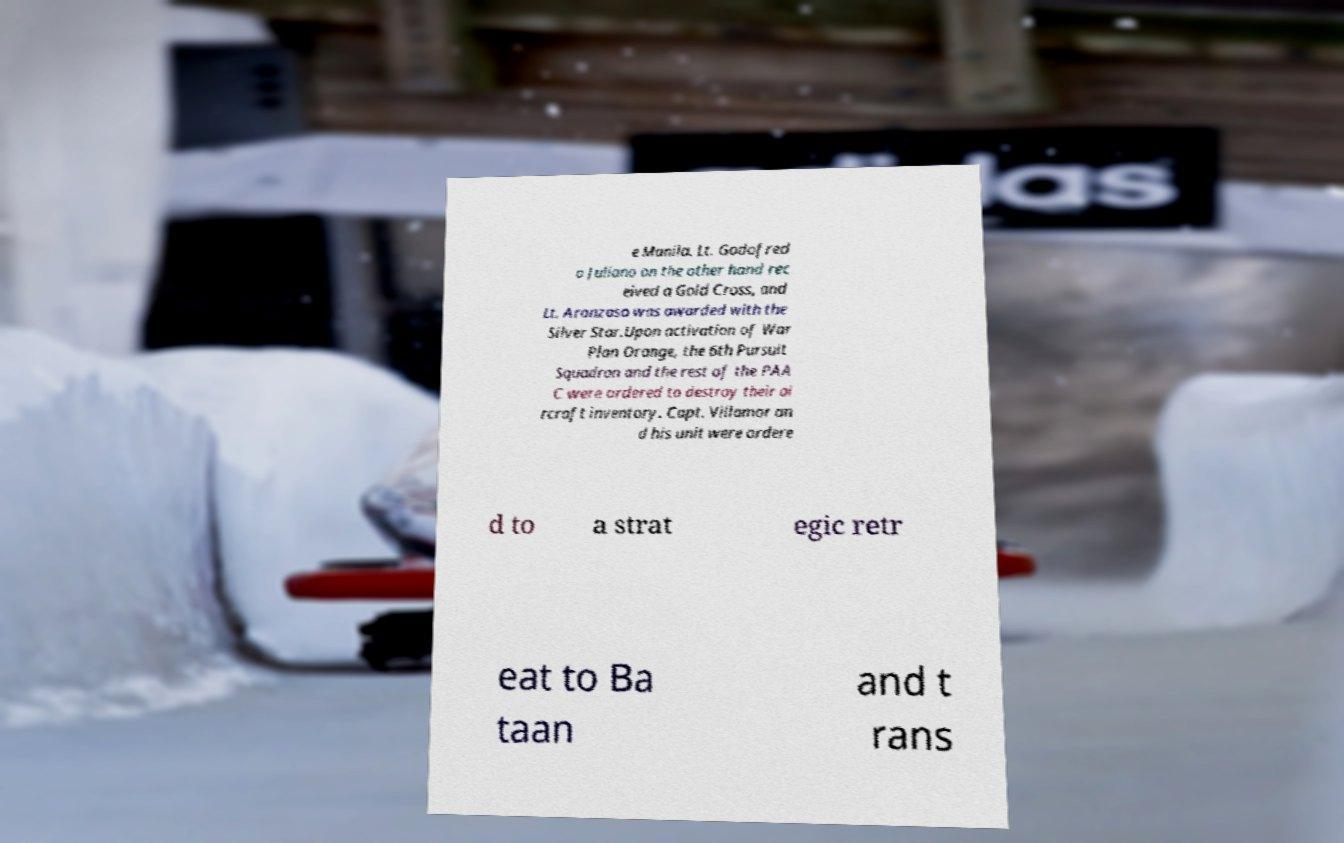Could you assist in decoding the text presented in this image and type it out clearly? e Manila. Lt. Godofred o Juliano on the other hand rec eived a Gold Cross, and Lt. Aranzaso was awarded with the Silver Star.Upon activation of War Plan Orange, the 6th Pursuit Squadron and the rest of the PAA C were ordered to destroy their ai rcraft inventory. Capt. Villamor an d his unit were ordere d to a strat egic retr eat to Ba taan and t rans 